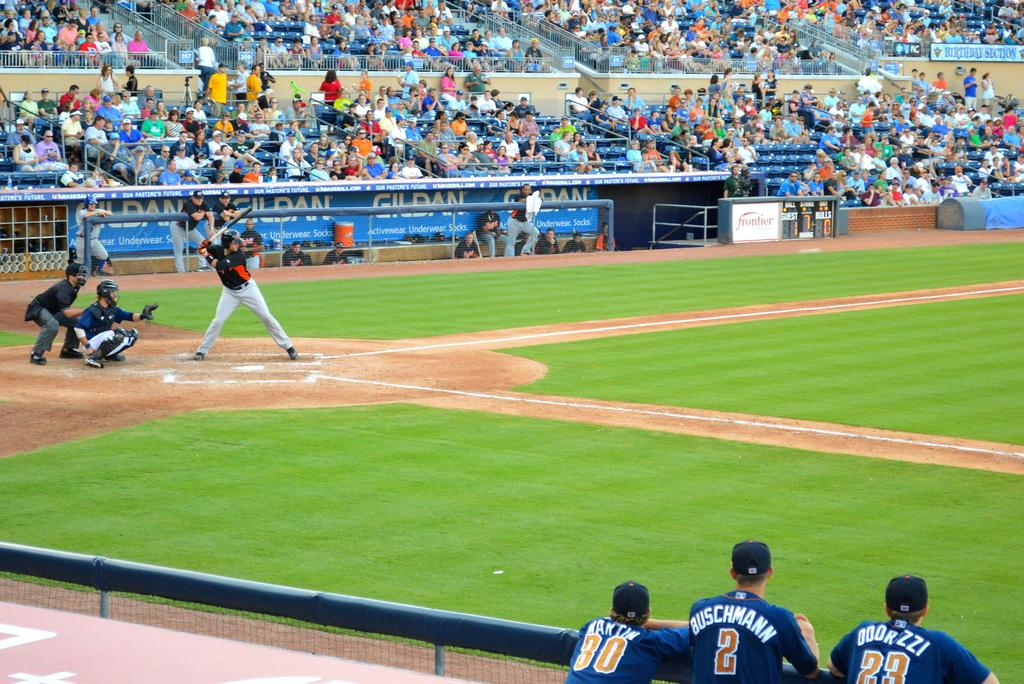<image>
Give a short and clear explanation of the subsequent image. a player has the number 2 on their jersey 